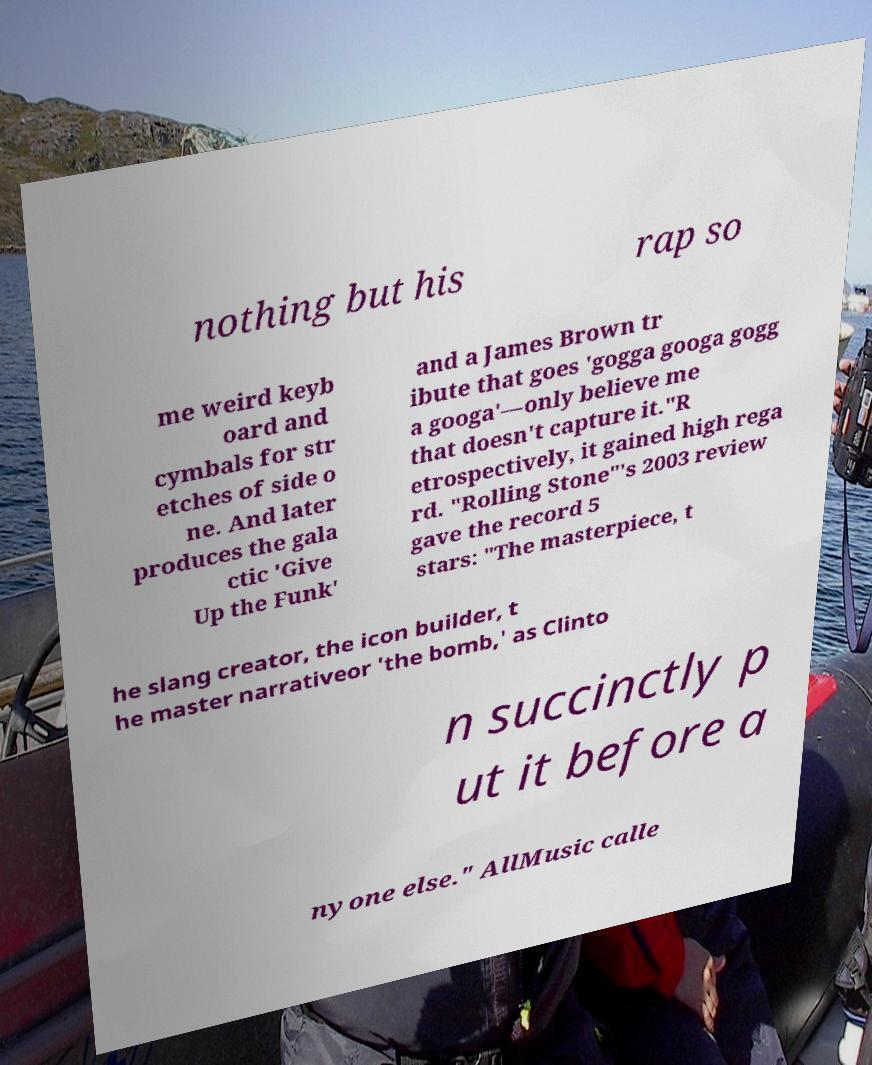There's text embedded in this image that I need extracted. Can you transcribe it verbatim? nothing but his rap so me weird keyb oard and cymbals for str etches of side o ne. And later produces the gala ctic 'Give Up the Funk' and a James Brown tr ibute that goes 'gogga googa gogg a googa'—only believe me that doesn't capture it."R etrospectively, it gained high rega rd. "Rolling Stone"'s 2003 review gave the record 5 stars: "The masterpiece, t he slang creator, the icon builder, t he master narrativeor 'the bomb,' as Clinto n succinctly p ut it before a nyone else." AllMusic calle 